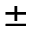Convert formula to latex. <formula><loc_0><loc_0><loc_500><loc_500>\pm</formula> 